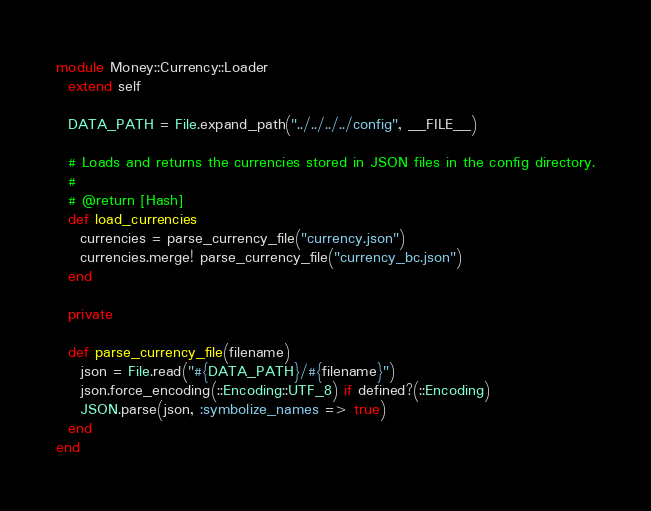<code> <loc_0><loc_0><loc_500><loc_500><_Ruby_>module Money::Currency::Loader
  extend self

  DATA_PATH = File.expand_path("../../../../config", __FILE__)

  # Loads and returns the currencies stored in JSON files in the config directory.
  #
  # @return [Hash]
  def load_currencies
    currencies = parse_currency_file("currency.json")
    currencies.merge! parse_currency_file("currency_bc.json")
  end

  private

  def parse_currency_file(filename)
    json = File.read("#{DATA_PATH}/#{filename}")
    json.force_encoding(::Encoding::UTF_8) if defined?(::Encoding)
    JSON.parse(json, :symbolize_names => true)
  end
end
</code> 